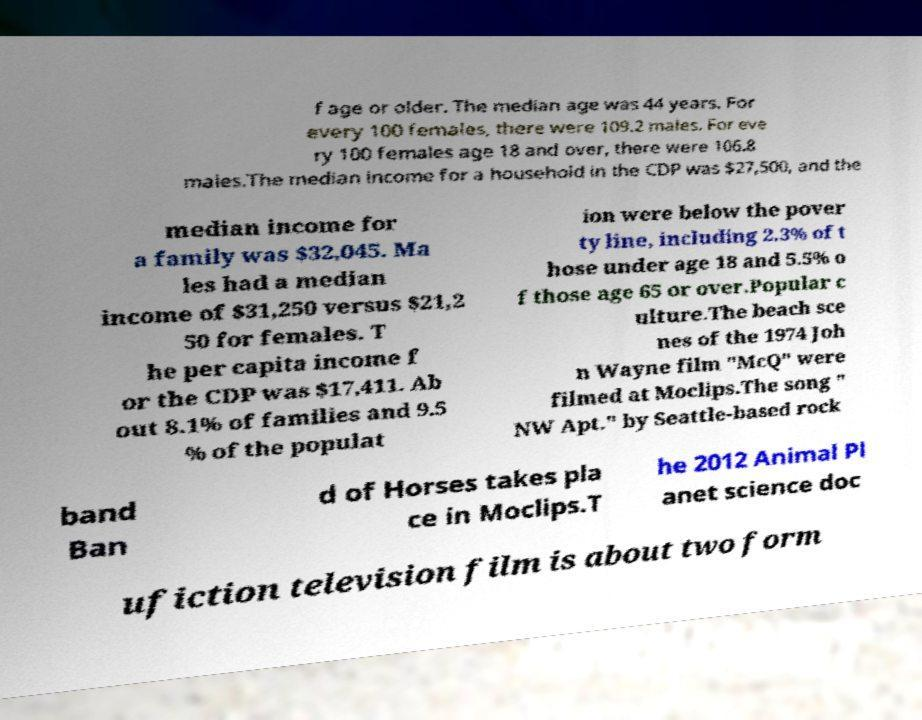Please identify and transcribe the text found in this image. f age or older. The median age was 44 years. For every 100 females, there were 109.2 males. For eve ry 100 females age 18 and over, there were 106.8 males.The median income for a household in the CDP was $27,500, and the median income for a family was $32,045. Ma les had a median income of $31,250 versus $21,2 50 for females. T he per capita income f or the CDP was $17,411. Ab out 8.1% of families and 9.5 % of the populat ion were below the pover ty line, including 2.3% of t hose under age 18 and 5.5% o f those age 65 or over.Popular c ulture.The beach sce nes of the 1974 Joh n Wayne film "McQ" were filmed at Moclips.The song " NW Apt." by Seattle-based rock band Ban d of Horses takes pla ce in Moclips.T he 2012 Animal Pl anet science doc ufiction television film is about two form 